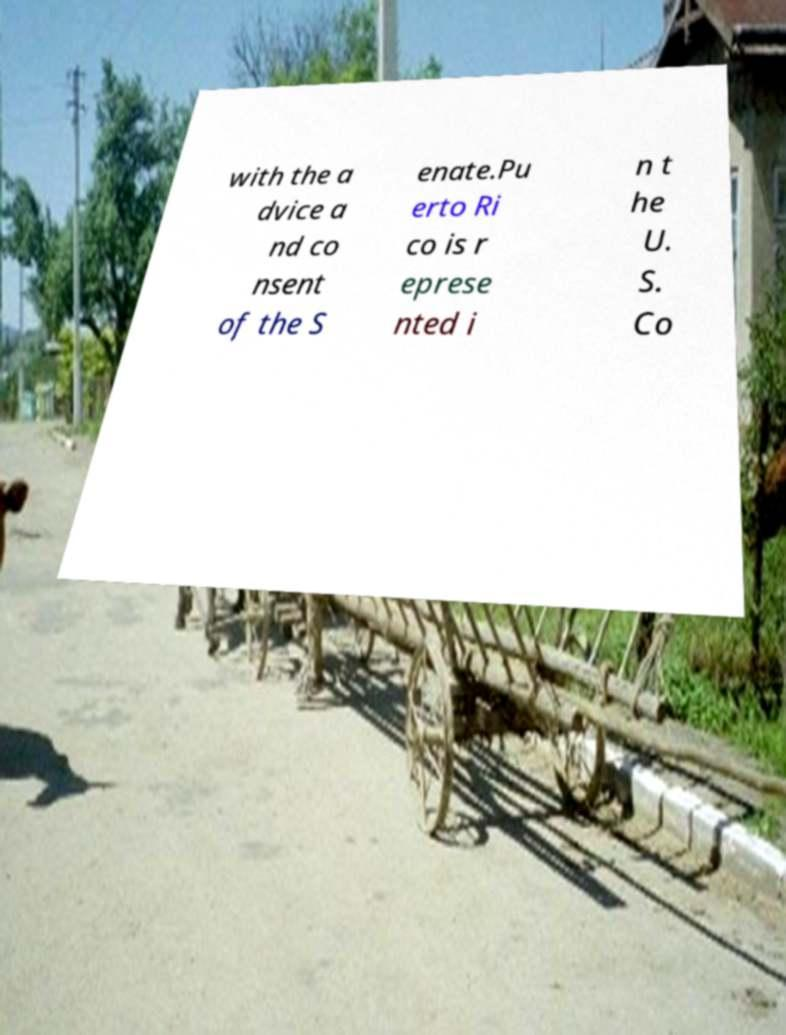Please identify and transcribe the text found in this image. with the a dvice a nd co nsent of the S enate.Pu erto Ri co is r eprese nted i n t he U. S. Co 